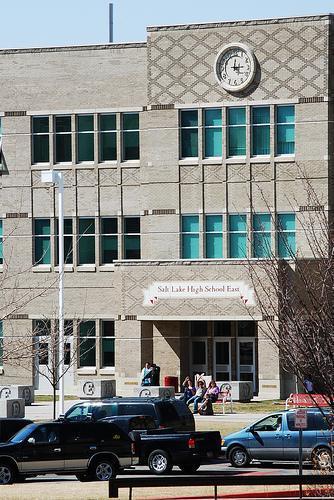How many people are sitting on the red bench?
Give a very brief answer. 3. 